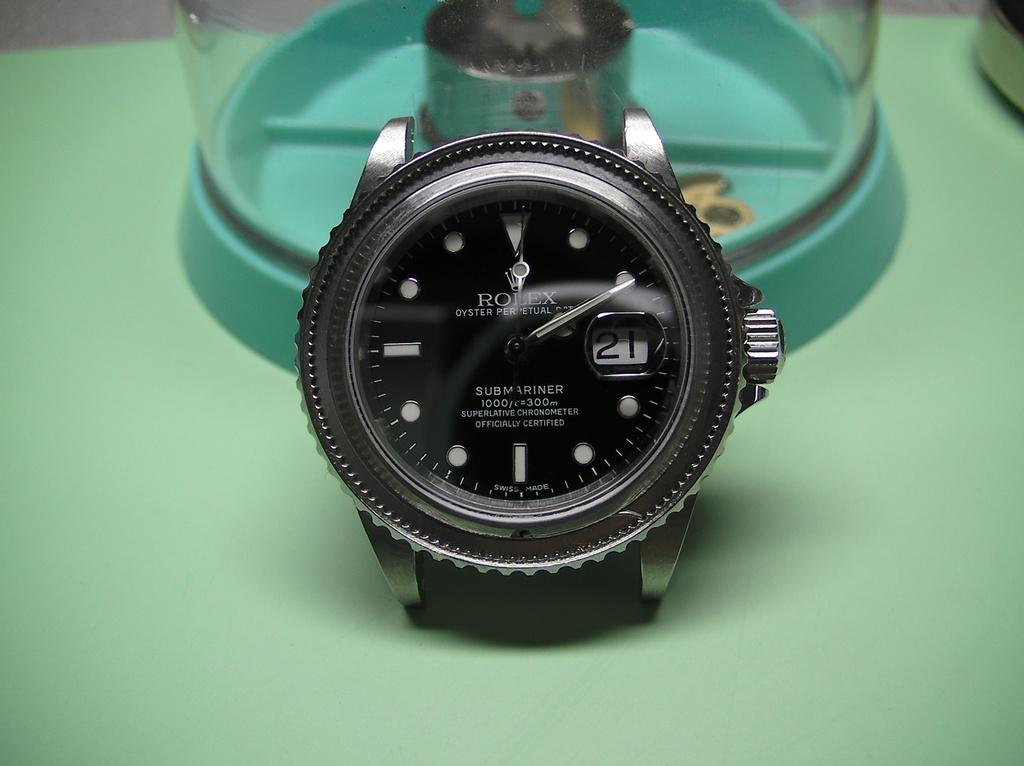What is the main subject in the foreground of the image? There is a watch in the foreground of the image. What can be seen in the background of the image? There are objects in the background of the image. How many chairs are visible in the scene? There is no mention of chairs in the image, so it is not possible to determine how many chairs are visible. 